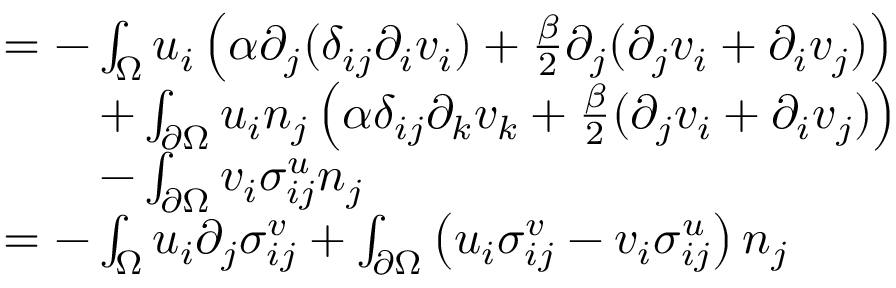Convert formula to latex. <formula><loc_0><loc_0><loc_500><loc_500>\begin{array} { r l } & { = - \int _ { \Omega } u _ { i } \left ( \alpha \partial _ { j } ( \delta _ { i j } \partial _ { i } v _ { i } ) + \frac { \beta } { 2 } \partial _ { j } ( \partial _ { j } v _ { i } + \partial _ { i } v _ { j } ) \right ) } \\ & { \quad + \int _ { \partial \Omega } u _ { i } n _ { j } \left ( \alpha \delta _ { i j } \partial _ { k } v _ { k } + \frac { \beta } { 2 } ( \partial _ { j } v _ { i } + \partial _ { i } v _ { j } ) \right ) } \\ & { \quad - \int _ { \partial \Omega } v _ { i } \sigma _ { i j } ^ { u } n _ { j } } \\ & { = - \int _ { \Omega } u _ { i } \partial _ { j } \sigma _ { i j } ^ { v } + \int _ { \partial \Omega } \left ( u _ { i } \sigma _ { i j } ^ { v } - v _ { i } \sigma _ { i j } ^ { u } \right ) n _ { j } } \end{array}</formula> 